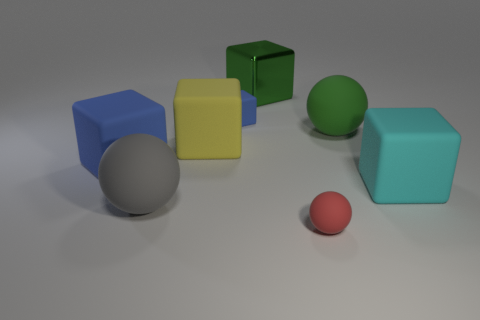Subtract 1 cubes. How many cubes are left? 4 Subtract all cyan cubes. How many cubes are left? 4 Subtract all small cubes. How many cubes are left? 4 Subtract all purple blocks. Subtract all purple cylinders. How many blocks are left? 5 Add 1 big rubber spheres. How many objects exist? 9 Subtract all spheres. How many objects are left? 5 Add 8 tiny blue things. How many tiny blue things are left? 9 Add 6 tiny red balls. How many tiny red balls exist? 7 Subtract 0 gray cubes. How many objects are left? 8 Subtract all big metal objects. Subtract all big rubber blocks. How many objects are left? 4 